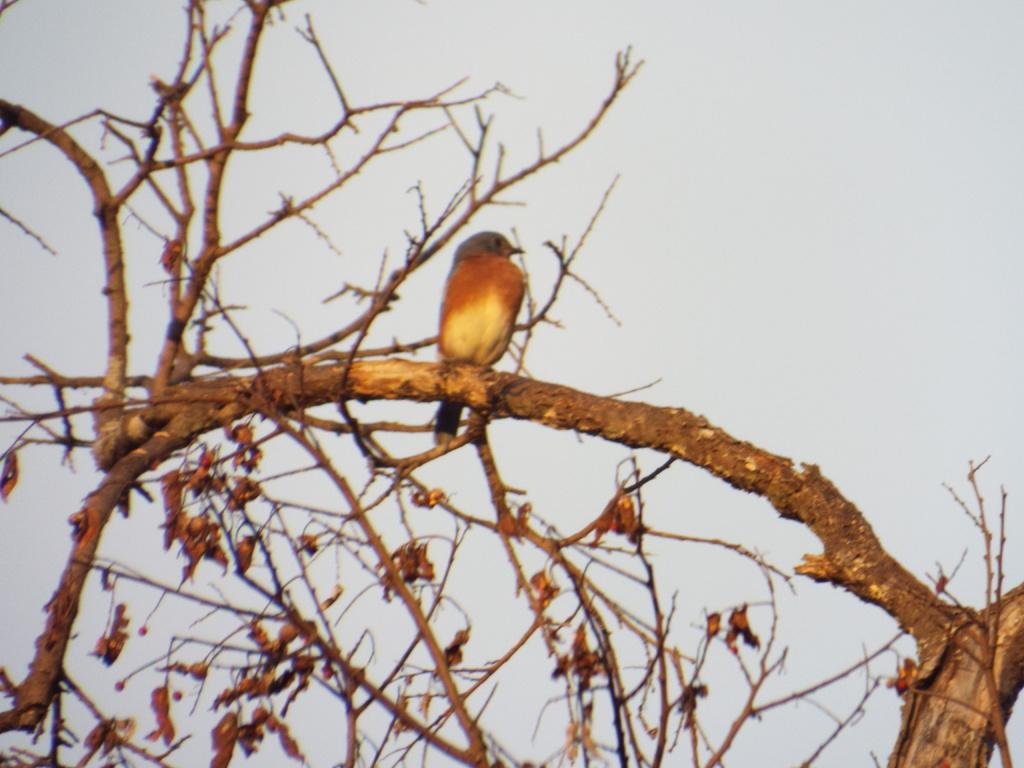Describe this image in one or two sentences. In this we can see there is a dry tree. On the tree there is a bird. In the background there is a sky. 